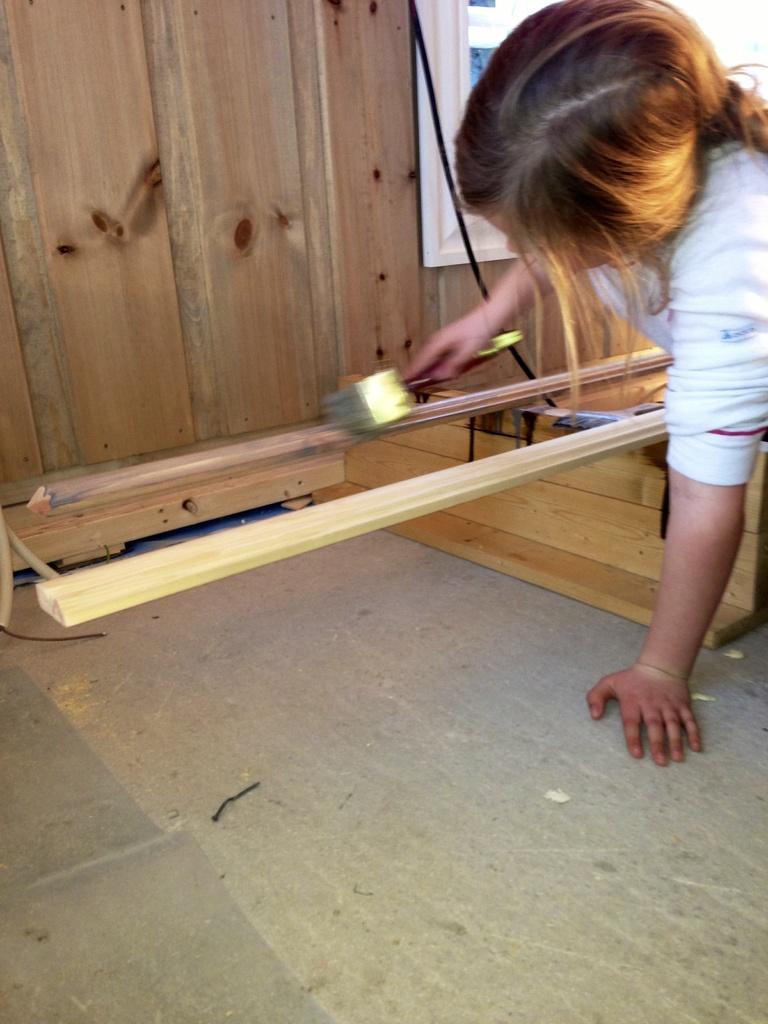Please provide a concise description of this image. In this image I can see a girl and I can see she is wearing white dress. I can also see she is holding a brush. 